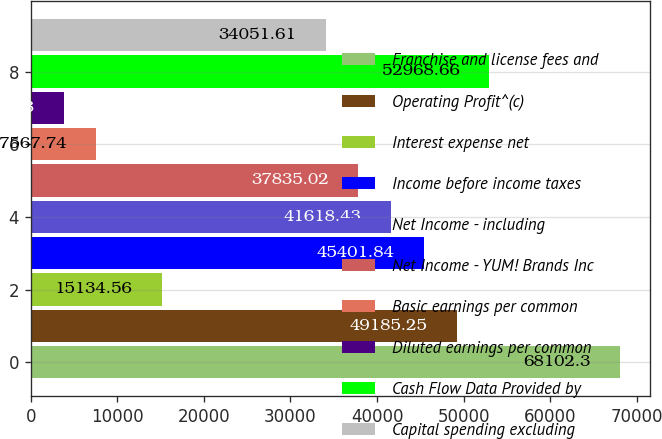Convert chart. <chart><loc_0><loc_0><loc_500><loc_500><bar_chart><fcel>Franchise and license fees and<fcel>Operating Profit^(c)<fcel>Interest expense net<fcel>Income before income taxes<fcel>Net Income - including<fcel>Net Income - YUM! Brands Inc<fcel>Basic earnings per common<fcel>Diluted earnings per common<fcel>Cash Flow Data Provided by<fcel>Capital spending excluding<nl><fcel>68102.3<fcel>49185.2<fcel>15134.6<fcel>45401.8<fcel>41618.4<fcel>37835<fcel>7567.74<fcel>3784.33<fcel>52968.7<fcel>34051.6<nl></chart> 